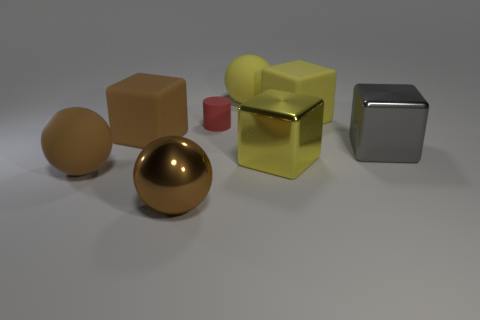There is a large brown object that is the same shape as the large gray shiny object; what is it made of?
Keep it short and to the point. Rubber. Are there any other things that are made of the same material as the tiny cylinder?
Your answer should be very brief. Yes. The tiny matte thing is what color?
Your answer should be compact. Red. Is the large shiny ball the same color as the tiny rubber object?
Provide a succinct answer. No. What number of yellow matte objects are to the right of the metallic object left of the tiny red thing?
Offer a very short reply. 2. What size is the sphere that is both in front of the gray cube and on the right side of the brown rubber ball?
Provide a short and direct response. Large. What is the material of the yellow sphere that is behind the tiny red thing?
Provide a succinct answer. Rubber. Are there any big brown metal objects that have the same shape as the small rubber thing?
Your answer should be very brief. No. How many other big shiny objects have the same shape as the gray shiny thing?
Keep it short and to the point. 1. There is a yellow matte object that is in front of the big yellow sphere; does it have the same size as the yellow block that is in front of the red matte object?
Your response must be concise. Yes. 